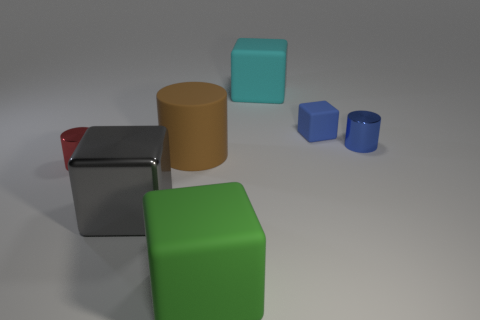Subtract all purple cubes. Subtract all purple cylinders. How many cubes are left? 4 Add 3 cyan metal spheres. How many objects exist? 10 Subtract all cubes. How many objects are left? 3 Subtract all small purple matte cylinders. Subtract all large green cubes. How many objects are left? 6 Add 6 big matte cylinders. How many big matte cylinders are left? 7 Add 3 big gray metal things. How many big gray metal things exist? 4 Subtract 0 gray balls. How many objects are left? 7 